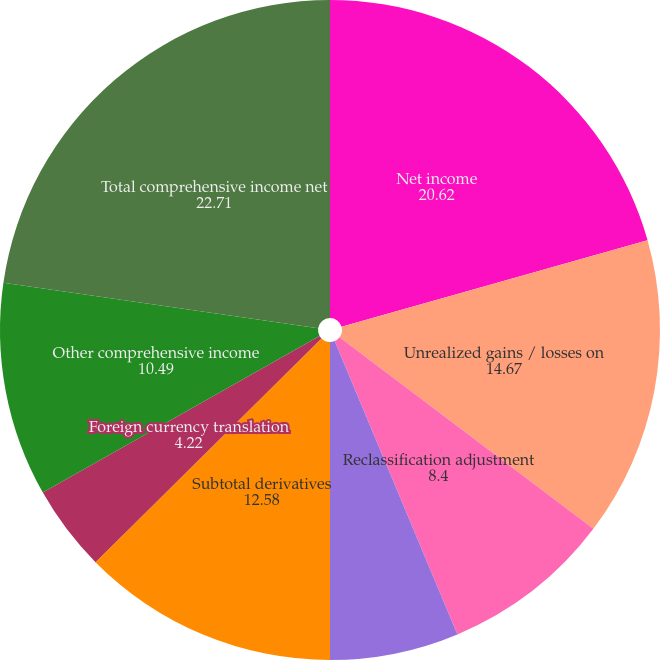<chart> <loc_0><loc_0><loc_500><loc_500><pie_chart><fcel>Net income<fcel>Unrealized gains / losses on<fcel>Reclassification adjustment<fcel>Subtotal available-for-sale<fcel>Subtotal derivatives<fcel>Foreign currency translation<fcel>Other comprehensive income<fcel>Total comprehensive income net<nl><fcel>20.62%<fcel>14.67%<fcel>8.4%<fcel>6.31%<fcel>12.58%<fcel>4.22%<fcel>10.49%<fcel>22.71%<nl></chart> 